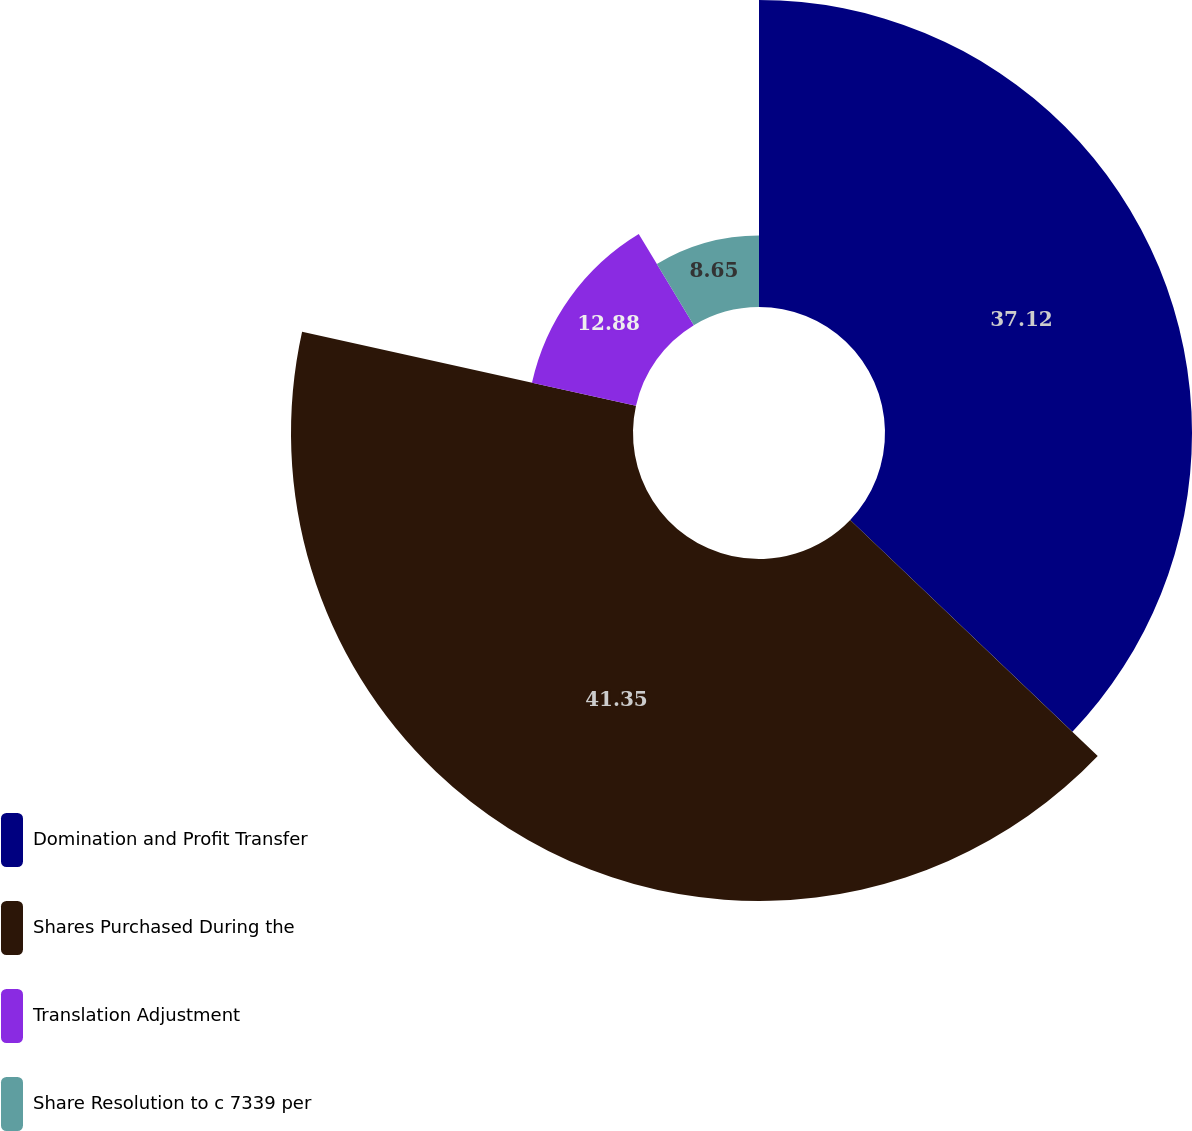Convert chart. <chart><loc_0><loc_0><loc_500><loc_500><pie_chart><fcel>Domination and Profit Transfer<fcel>Shares Purchased During the<fcel>Translation Adjustment<fcel>Share Resolution to c 7339 per<nl><fcel>37.12%<fcel>41.35%<fcel>12.88%<fcel>8.65%<nl></chart> 